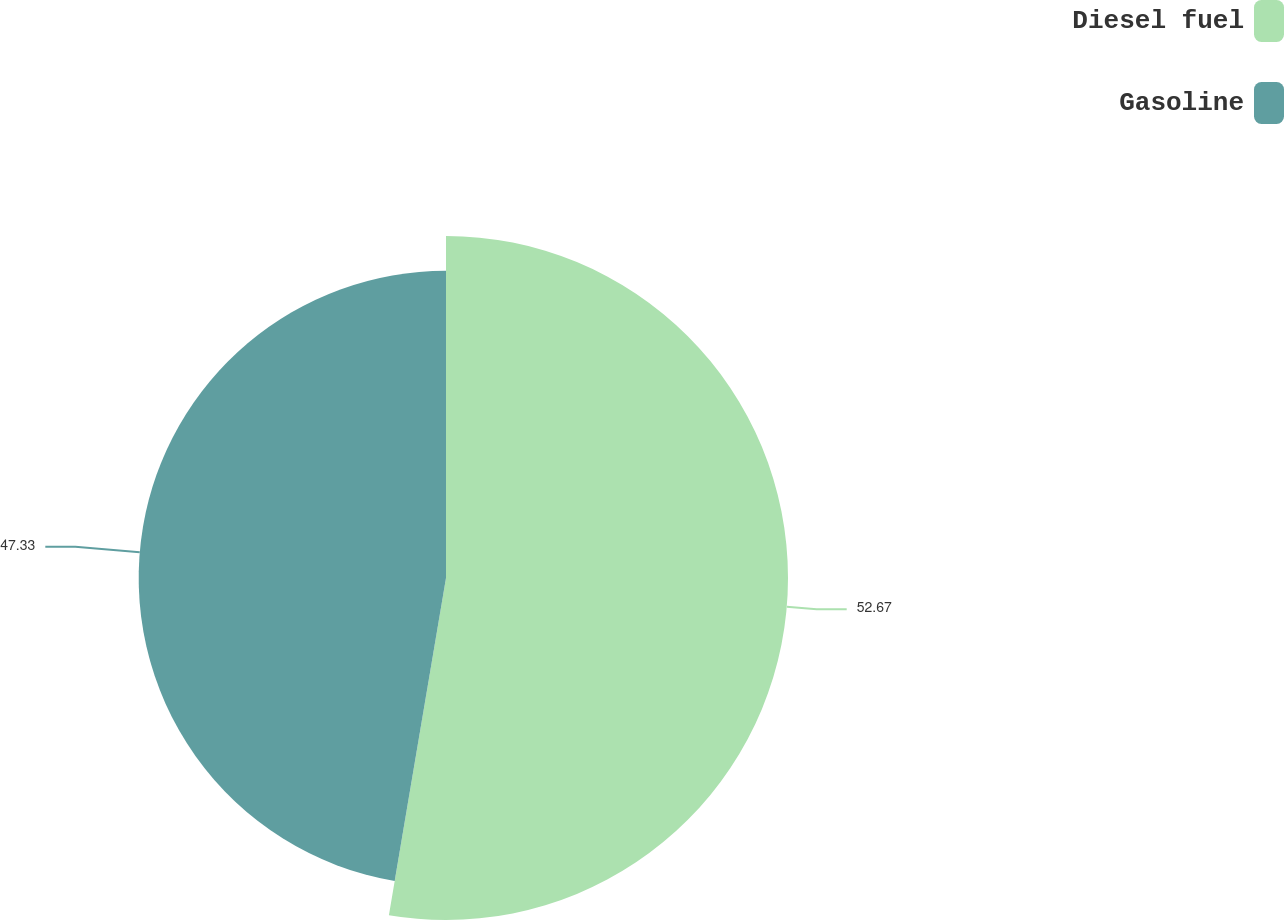<chart> <loc_0><loc_0><loc_500><loc_500><pie_chart><fcel>Diesel fuel<fcel>Gasoline<nl><fcel>52.67%<fcel>47.33%<nl></chart> 